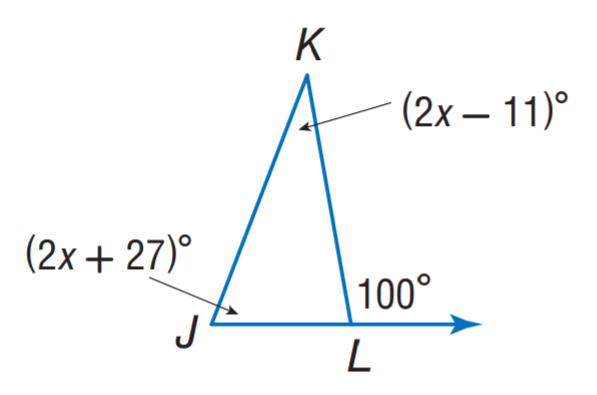Answer the mathemtical geometry problem and directly provide the correct option letter.
Question: Find m \angle J K L.
Choices: A: 21 B: 31 C: 43 D: 84 B 